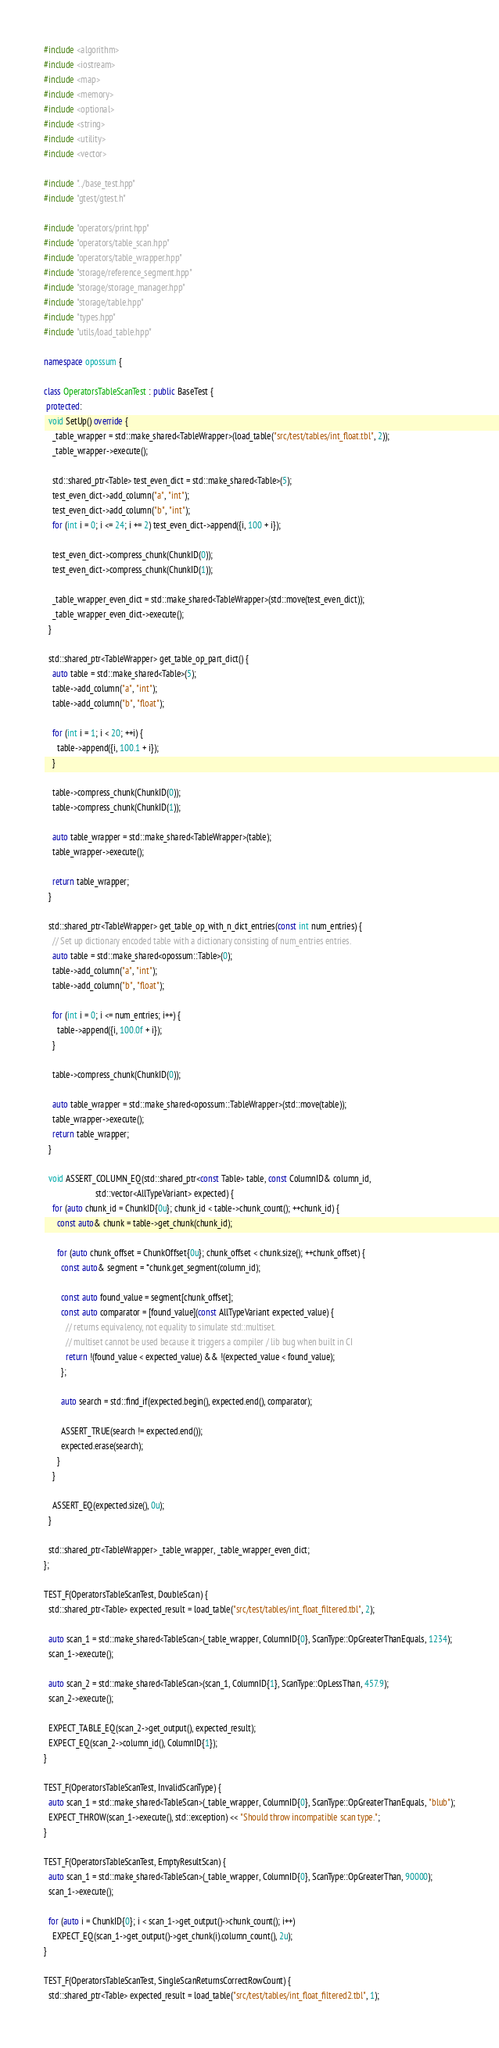<code> <loc_0><loc_0><loc_500><loc_500><_C++_>#include <algorithm>
#include <iostream>
#include <map>
#include <memory>
#include <optional>
#include <string>
#include <utility>
#include <vector>

#include "../base_test.hpp"
#include "gtest/gtest.h"

#include "operators/print.hpp"
#include "operators/table_scan.hpp"
#include "operators/table_wrapper.hpp"
#include "storage/reference_segment.hpp"
#include "storage/storage_manager.hpp"
#include "storage/table.hpp"
#include "types.hpp"
#include "utils/load_table.hpp"

namespace opossum {

class OperatorsTableScanTest : public BaseTest {
 protected:
  void SetUp() override {
    _table_wrapper = std::make_shared<TableWrapper>(load_table("src/test/tables/int_float.tbl", 2));
    _table_wrapper->execute();

    std::shared_ptr<Table> test_even_dict = std::make_shared<Table>(5);
    test_even_dict->add_column("a", "int");
    test_even_dict->add_column("b", "int");
    for (int i = 0; i <= 24; i += 2) test_even_dict->append({i, 100 + i});

    test_even_dict->compress_chunk(ChunkID(0));
    test_even_dict->compress_chunk(ChunkID(1));

    _table_wrapper_even_dict = std::make_shared<TableWrapper>(std::move(test_even_dict));
    _table_wrapper_even_dict->execute();
  }

  std::shared_ptr<TableWrapper> get_table_op_part_dict() {
    auto table = std::make_shared<Table>(5);
    table->add_column("a", "int");
    table->add_column("b", "float");

    for (int i = 1; i < 20; ++i) {
      table->append({i, 100.1 + i});
    }

    table->compress_chunk(ChunkID(0));
    table->compress_chunk(ChunkID(1));

    auto table_wrapper = std::make_shared<TableWrapper>(table);
    table_wrapper->execute();

    return table_wrapper;
  }

  std::shared_ptr<TableWrapper> get_table_op_with_n_dict_entries(const int num_entries) {
    // Set up dictionary encoded table with a dictionary consisting of num_entries entries.
    auto table = std::make_shared<opossum::Table>(0);
    table->add_column("a", "int");
    table->add_column("b", "float");

    for (int i = 0; i <= num_entries; i++) {
      table->append({i, 100.0f + i});
    }

    table->compress_chunk(ChunkID(0));

    auto table_wrapper = std::make_shared<opossum::TableWrapper>(std::move(table));
    table_wrapper->execute();
    return table_wrapper;
  }

  void ASSERT_COLUMN_EQ(std::shared_ptr<const Table> table, const ColumnID& column_id,
                        std::vector<AllTypeVariant> expected) {
    for (auto chunk_id = ChunkID{0u}; chunk_id < table->chunk_count(); ++chunk_id) {
      const auto& chunk = table->get_chunk(chunk_id);

      for (auto chunk_offset = ChunkOffset{0u}; chunk_offset < chunk.size(); ++chunk_offset) {
        const auto& segment = *chunk.get_segment(column_id);

        const auto found_value = segment[chunk_offset];
        const auto comparator = [found_value](const AllTypeVariant expected_value) {
          // returns equivalency, not equality to simulate std::multiset.
          // multiset cannot be used because it triggers a compiler / lib bug when built in CI
          return !(found_value < expected_value) && !(expected_value < found_value);
        };

        auto search = std::find_if(expected.begin(), expected.end(), comparator);

        ASSERT_TRUE(search != expected.end());
        expected.erase(search);
      }
    }

    ASSERT_EQ(expected.size(), 0u);
  }

  std::shared_ptr<TableWrapper> _table_wrapper, _table_wrapper_even_dict;
};

TEST_F(OperatorsTableScanTest, DoubleScan) {
  std::shared_ptr<Table> expected_result = load_table("src/test/tables/int_float_filtered.tbl", 2);

  auto scan_1 = std::make_shared<TableScan>(_table_wrapper, ColumnID{0}, ScanType::OpGreaterThanEquals, 1234);
  scan_1->execute();

  auto scan_2 = std::make_shared<TableScan>(scan_1, ColumnID{1}, ScanType::OpLessThan, 457.9);
  scan_2->execute();

  EXPECT_TABLE_EQ(scan_2->get_output(), expected_result);
  EXPECT_EQ(scan_2->column_id(), ColumnID{1});
}

TEST_F(OperatorsTableScanTest, InvalidScanType) {
  auto scan_1 = std::make_shared<TableScan>(_table_wrapper, ColumnID{0}, ScanType::OpGreaterThanEquals, "blub");
  EXPECT_THROW(scan_1->execute(), std::exception) << "Should throw incompatible scan type.";
}

TEST_F(OperatorsTableScanTest, EmptyResultScan) {
  auto scan_1 = std::make_shared<TableScan>(_table_wrapper, ColumnID{0}, ScanType::OpGreaterThan, 90000);
  scan_1->execute();

  for (auto i = ChunkID{0}; i < scan_1->get_output()->chunk_count(); i++)
    EXPECT_EQ(scan_1->get_output()->get_chunk(i).column_count(), 2u);
}

TEST_F(OperatorsTableScanTest, SingleScanReturnsCorrectRowCount) {
  std::shared_ptr<Table> expected_result = load_table("src/test/tables/int_float_filtered2.tbl", 1);
</code> 